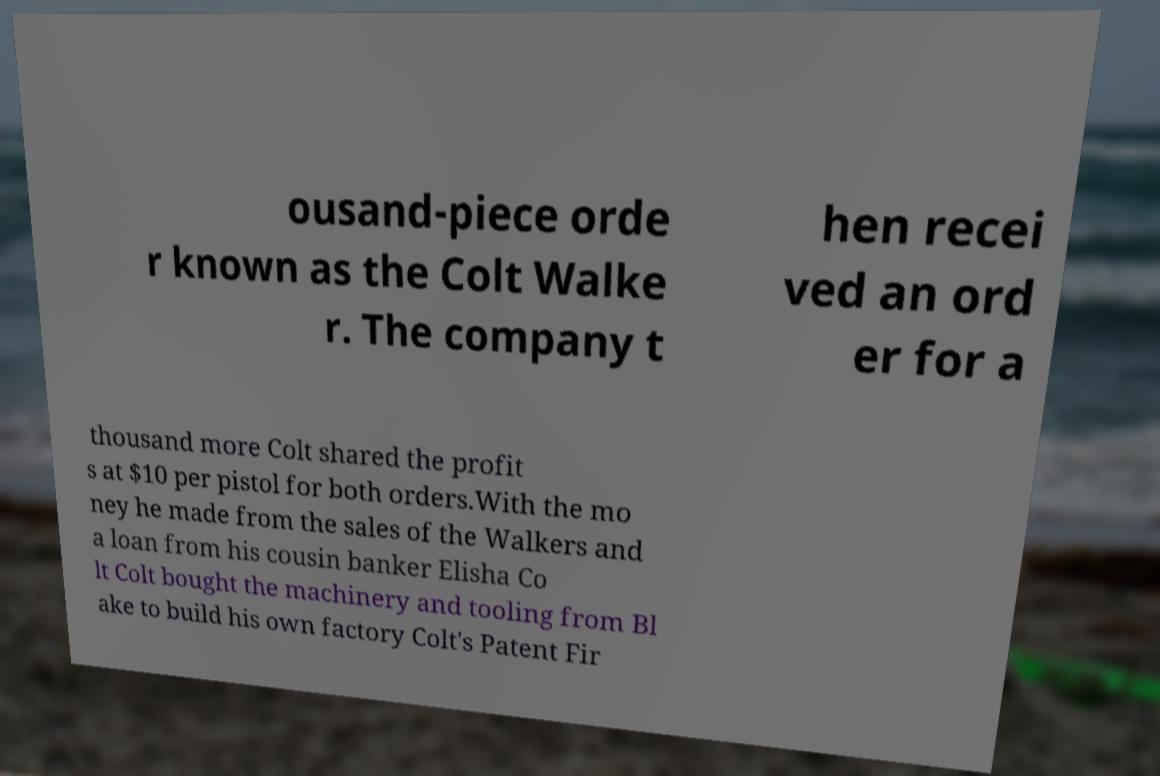For documentation purposes, I need the text within this image transcribed. Could you provide that? ousand-piece orde r known as the Colt Walke r. The company t hen recei ved an ord er for a thousand more Colt shared the profit s at $10 per pistol for both orders.With the mo ney he made from the sales of the Walkers and a loan from his cousin banker Elisha Co lt Colt bought the machinery and tooling from Bl ake to build his own factory Colt's Patent Fir 